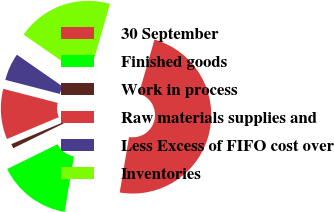Convert chart. <chart><loc_0><loc_0><loc_500><loc_500><pie_chart><fcel>30 September<fcel>Finished goods<fcel>Work in process<fcel>Raw materials supplies and<fcel>Less Excess of FIFO cost over<fcel>Inventories<nl><fcel>48.17%<fcel>15.09%<fcel>0.91%<fcel>10.37%<fcel>5.64%<fcel>19.82%<nl></chart> 